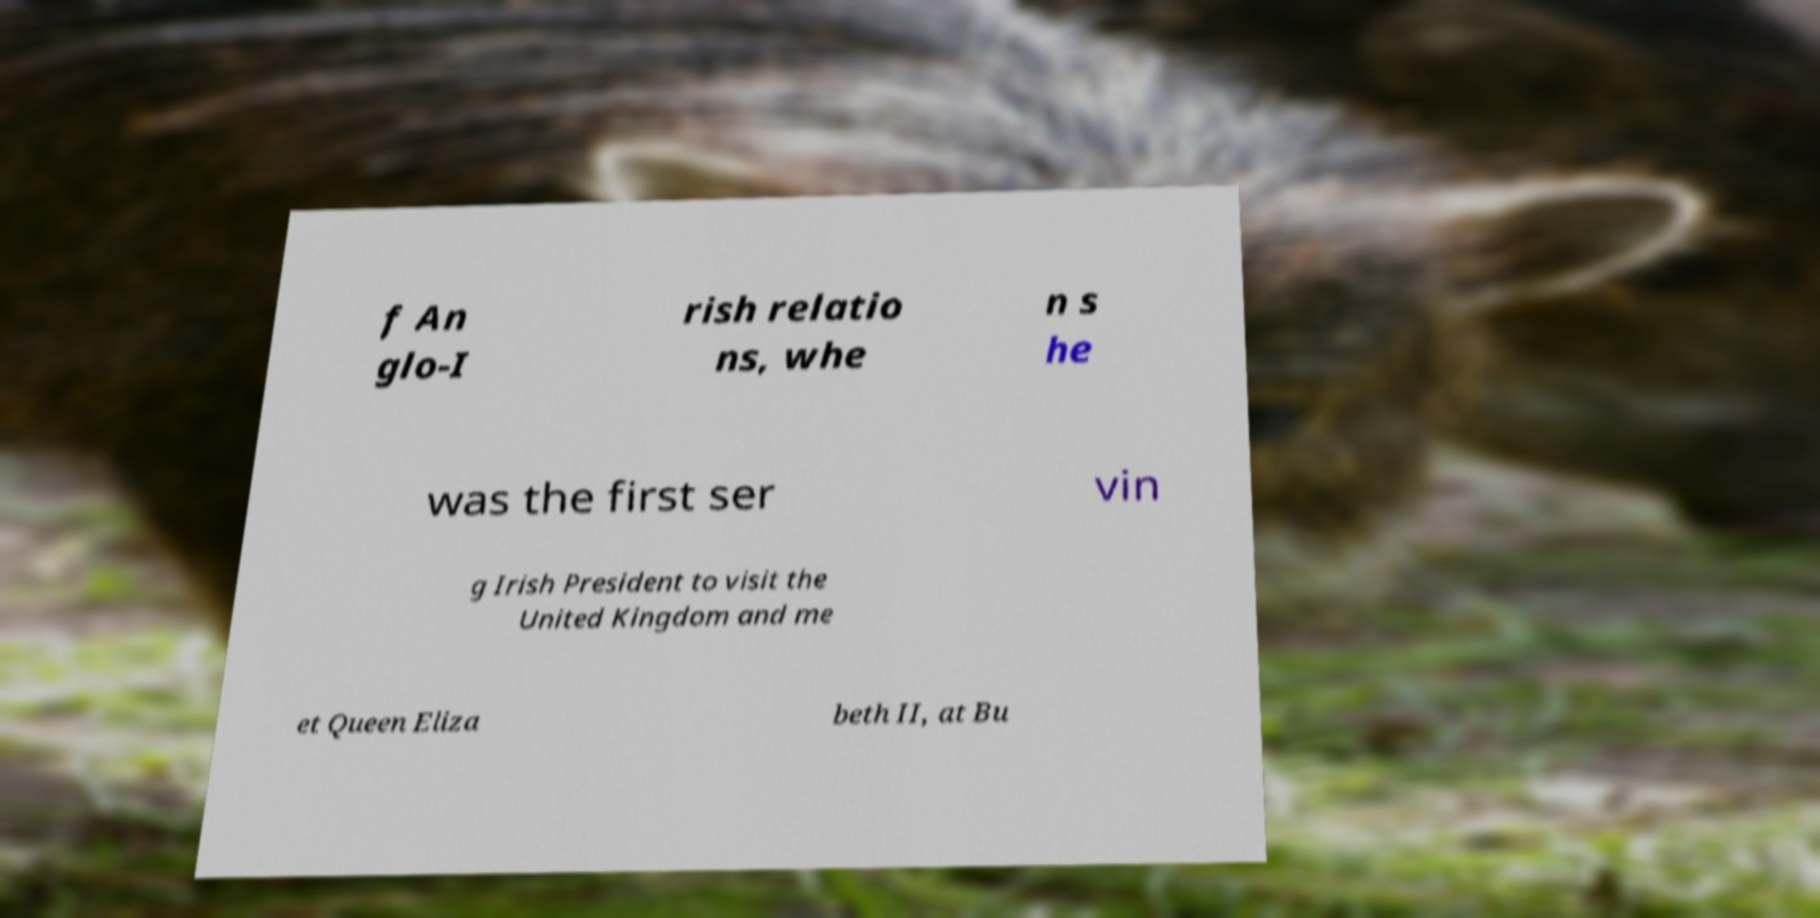I need the written content from this picture converted into text. Can you do that? f An glo-I rish relatio ns, whe n s he was the first ser vin g Irish President to visit the United Kingdom and me et Queen Eliza beth II, at Bu 